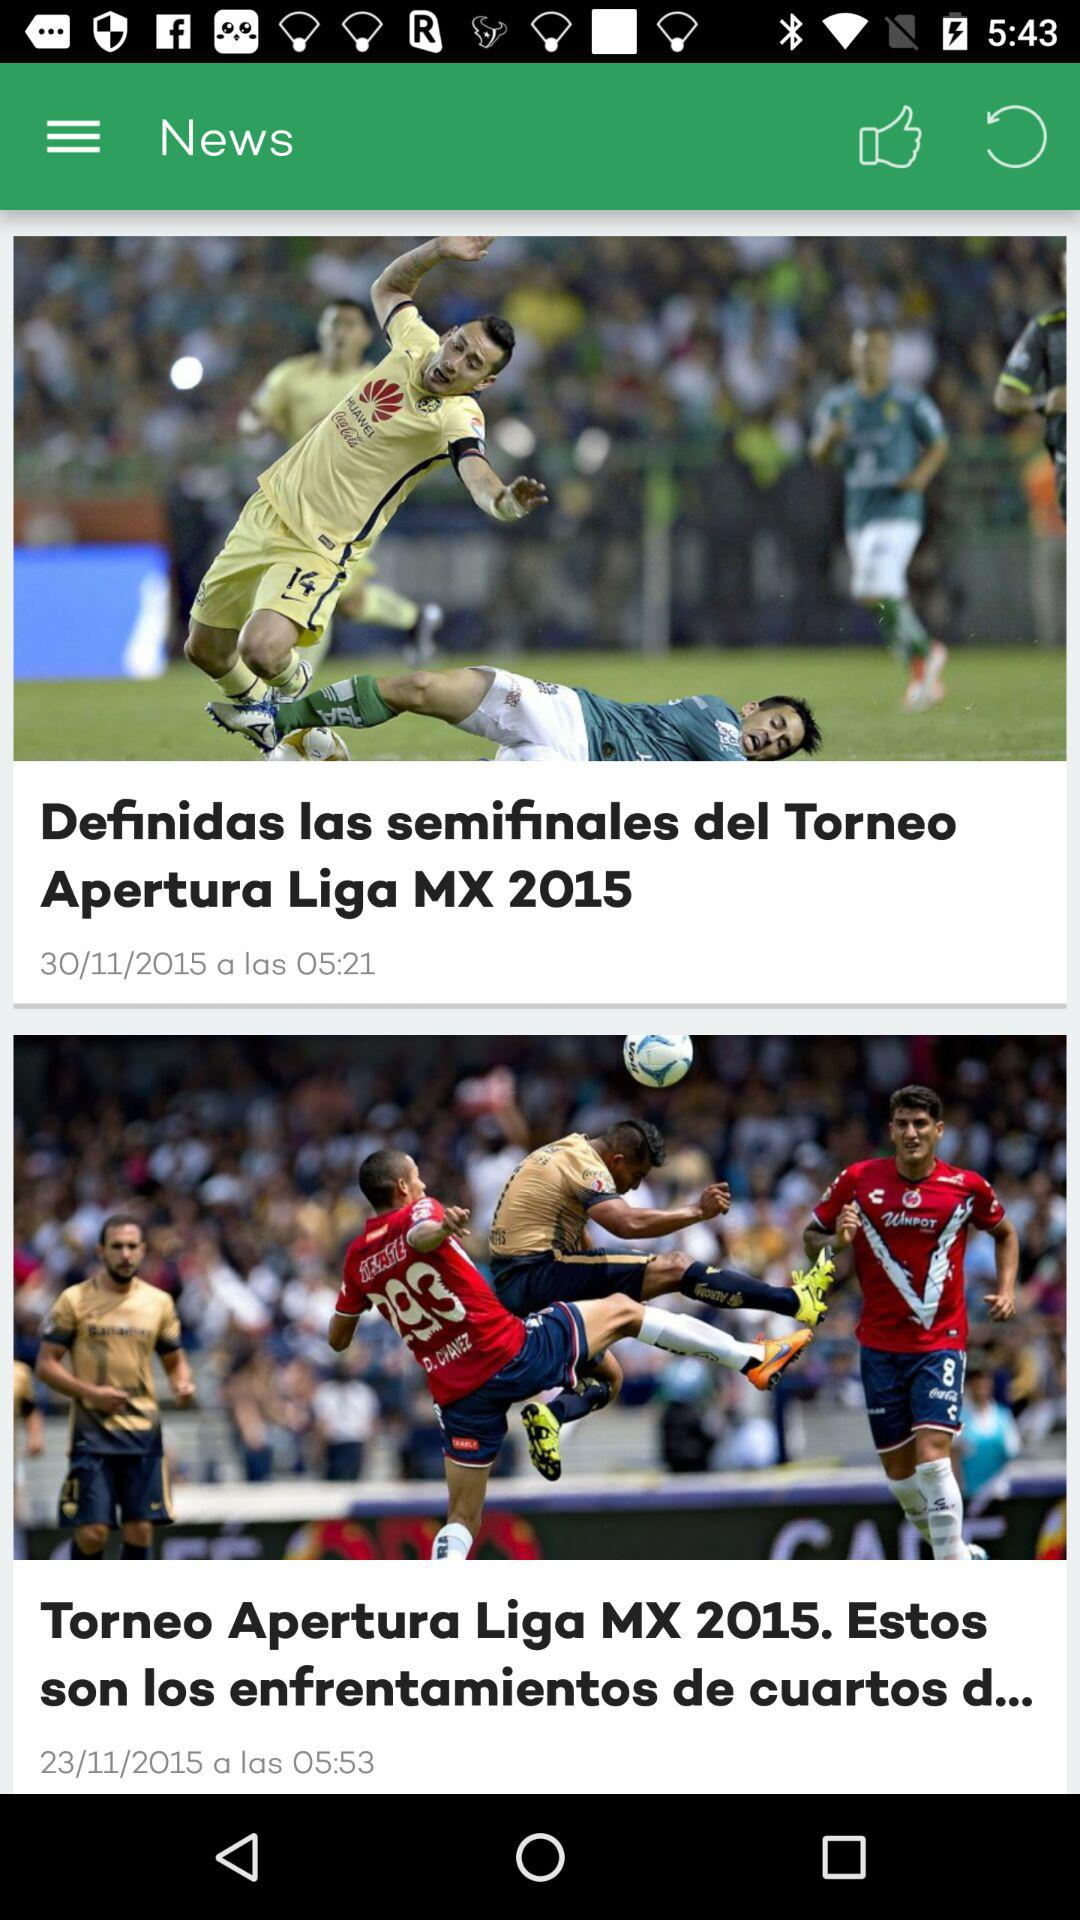What is the posted date of "Definidas las semifinales"? The posted date of "Definidas las semifinales" is November 30, 2015. 